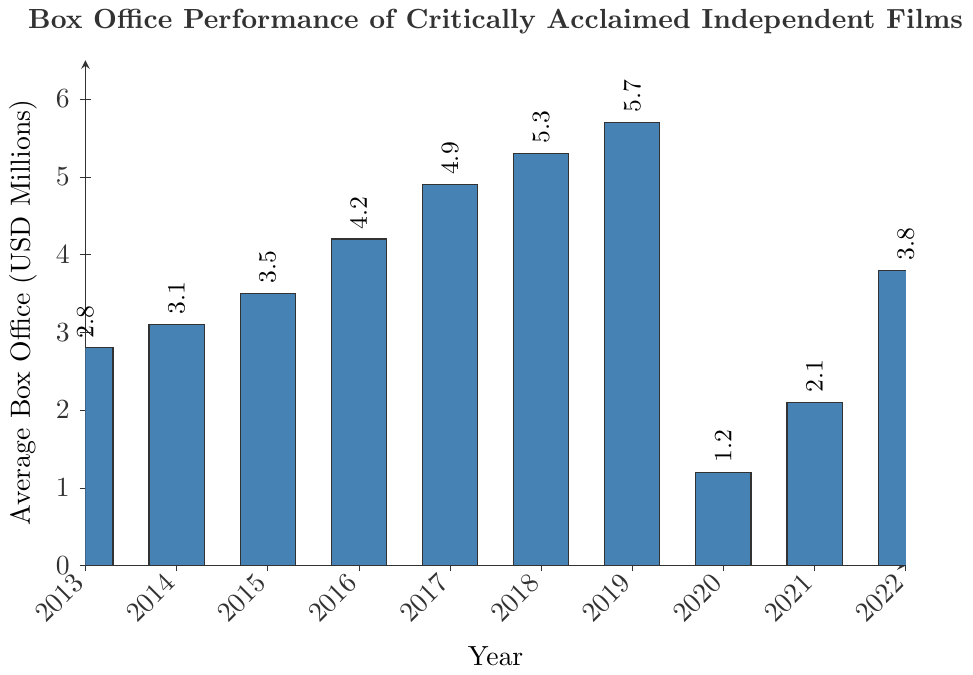Which year had the highest average box office for critically acclaimed independent films? By looking at the figure, we can see that the bar for 2019 is the tallest, indicating that 2019 had the highest average box office.
Answer: 2019 Which year had the lowest average box office performance? By observing the height of the bars in the figure, the shortest bar corresponds to 2020, indicating it had the lowest average box office performance.
Answer: 2020 What's the difference in average box office between 2019 and 2020? The average box office for 2019 is 5.7 million, and for 2020 it is 1.2 million. Subtracting 1.2 million from 5.7 million gives a difference of 4.5 million.
Answer: 4.5 million During which years did the average box office increase compared to the previous year? Comparing the height of the bars year by year, we see increases from 2013 to 2014, 2014 to 2015, 2015 to 2016, 2016 to 2017, 2017 to 2018, and from 2021 to 2022.
Answer: 2013-2014, 2014-2015, 2015-2016, 2016-2017, 2017-2018, 2021-2022 What is the average box office over the decade from 2013 to 2022? Adding the box office values from each year: 2.8 + 3.1 + 3.5 + 4.2 + 4.9 + 5.3 + 5.7 + 1.2 + 2.1 + 3.8, we get 36.6. Dividing by 10 (number of years) gives the average box office of 3.66 million.
Answer: 3.66 million Which two consecutive years saw the largest drop in average box office performance? Comparing the drop between pairs of consecutive years, the drop between 2019 (5.7 million) and 2020 (1.2 million) is the largest, at 4.5 million.
Answer: 2019-2020 How many years had an average box office higher than 4 million? By observing the heights of the bars, those corresponding to 2016, 2017, 2018, and 2019 are all above 4 million. Thus, there are 4 years with an average box office higher than 4 million.
Answer: 4 By how much did the average box office change from 2021 to 2022? The average box office was 2.1 million in 2021 and increased to 3.8 million in 2022. Subtracting 2.1 million from 3.8 million gives an increase of 1.7 million.
Answer: 1.7 million 